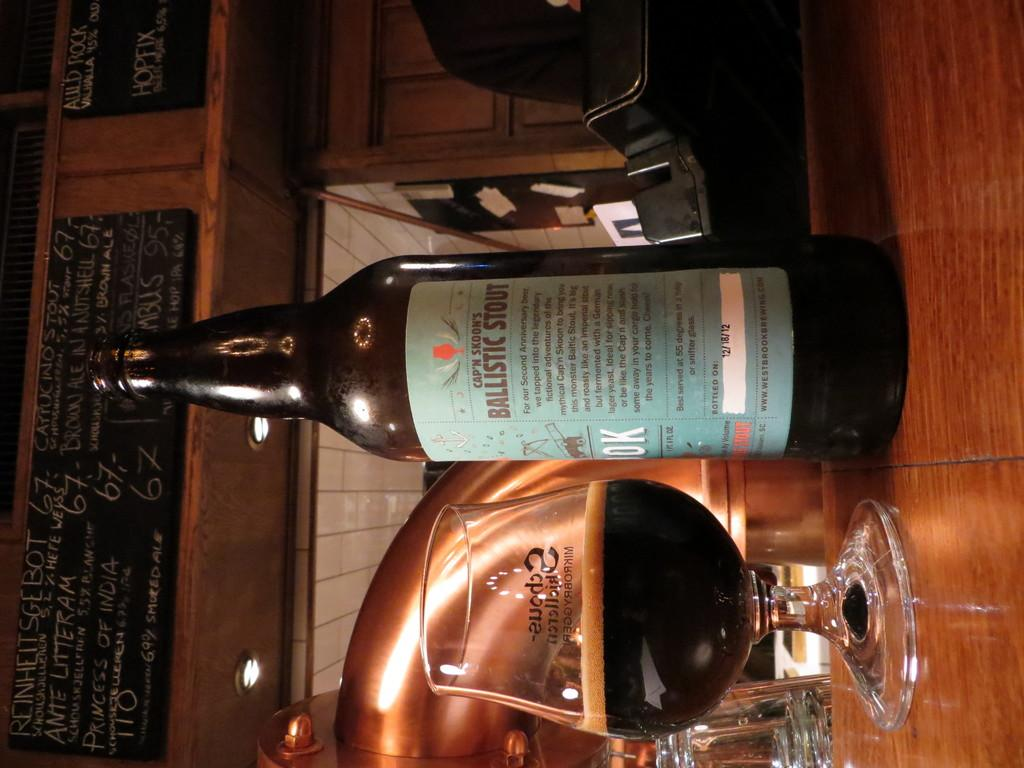<image>
Relay a brief, clear account of the picture shown. A bottle of cap'n Skoon's Ballistic stout is sitting next to a half full glass of liquid. 